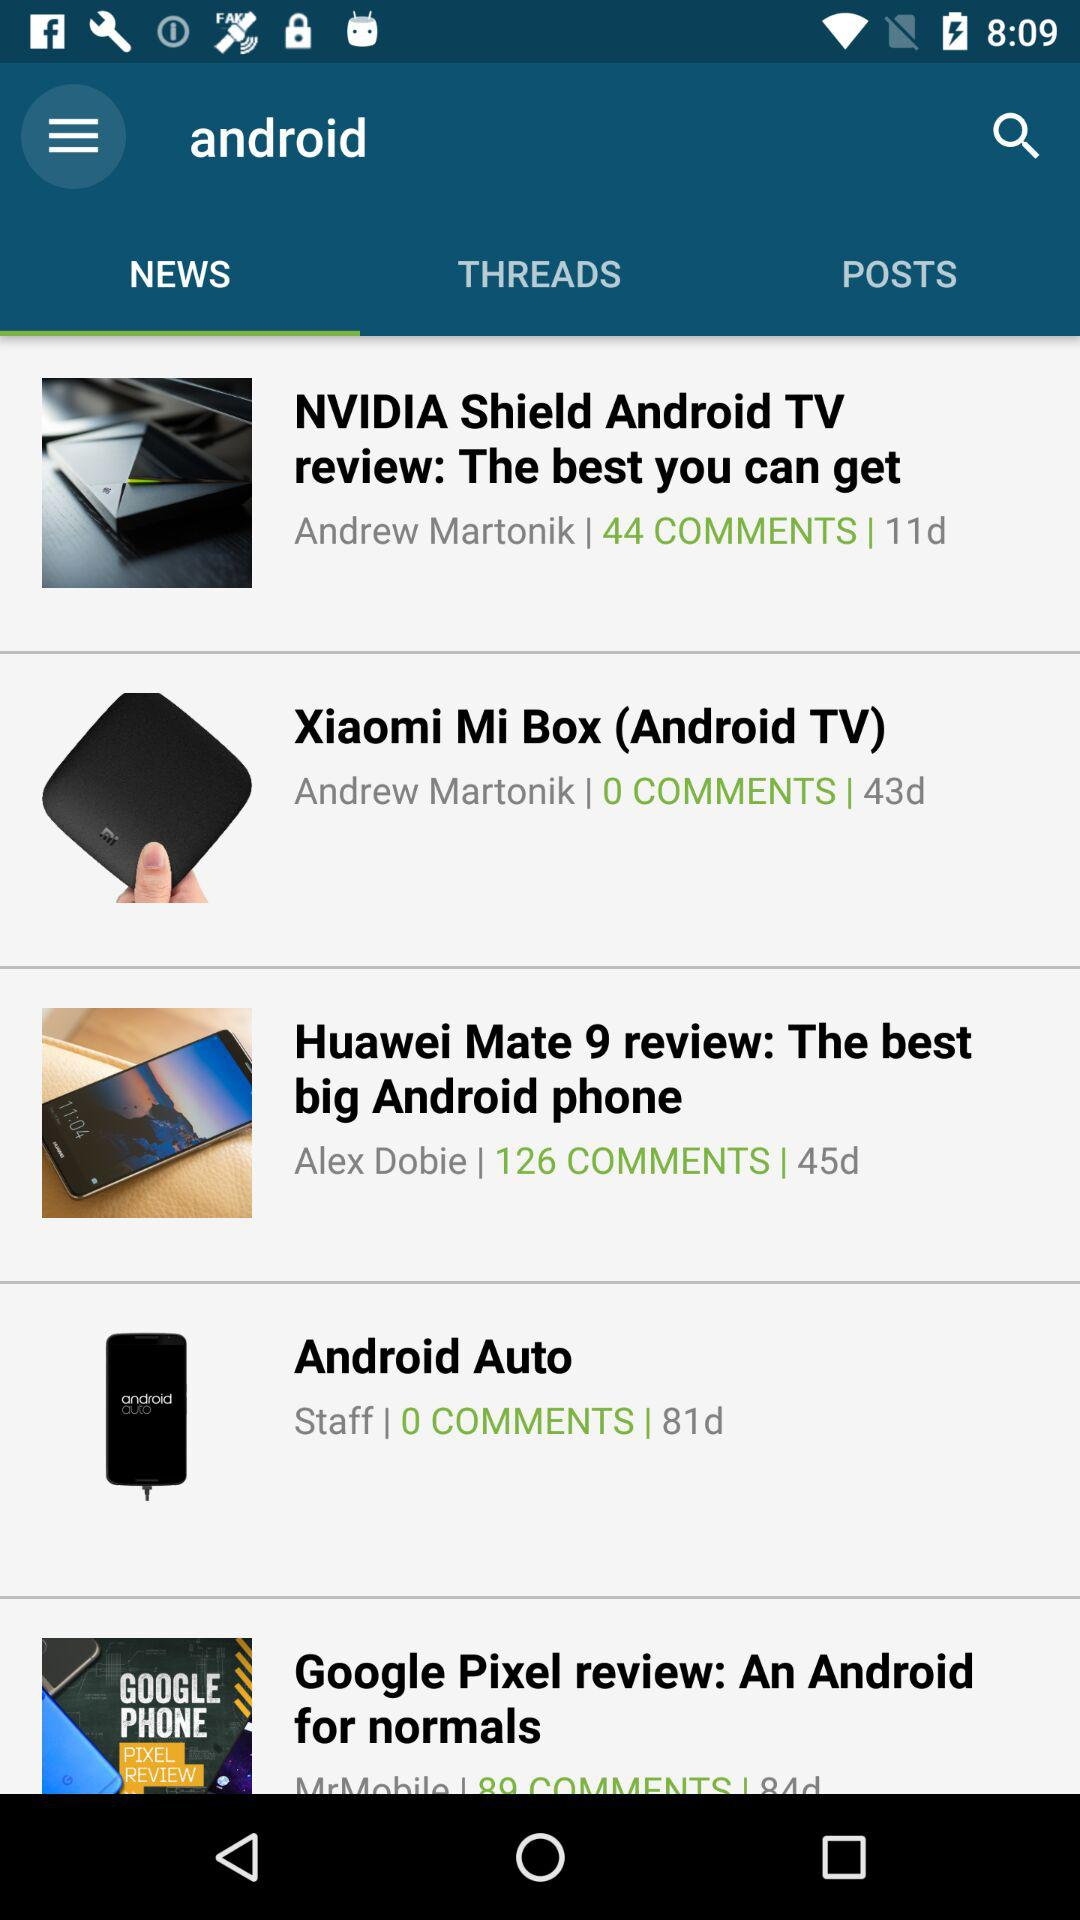What is the author name of the "Huawei Mate 9 review"? The author name is Alex Dobie. 